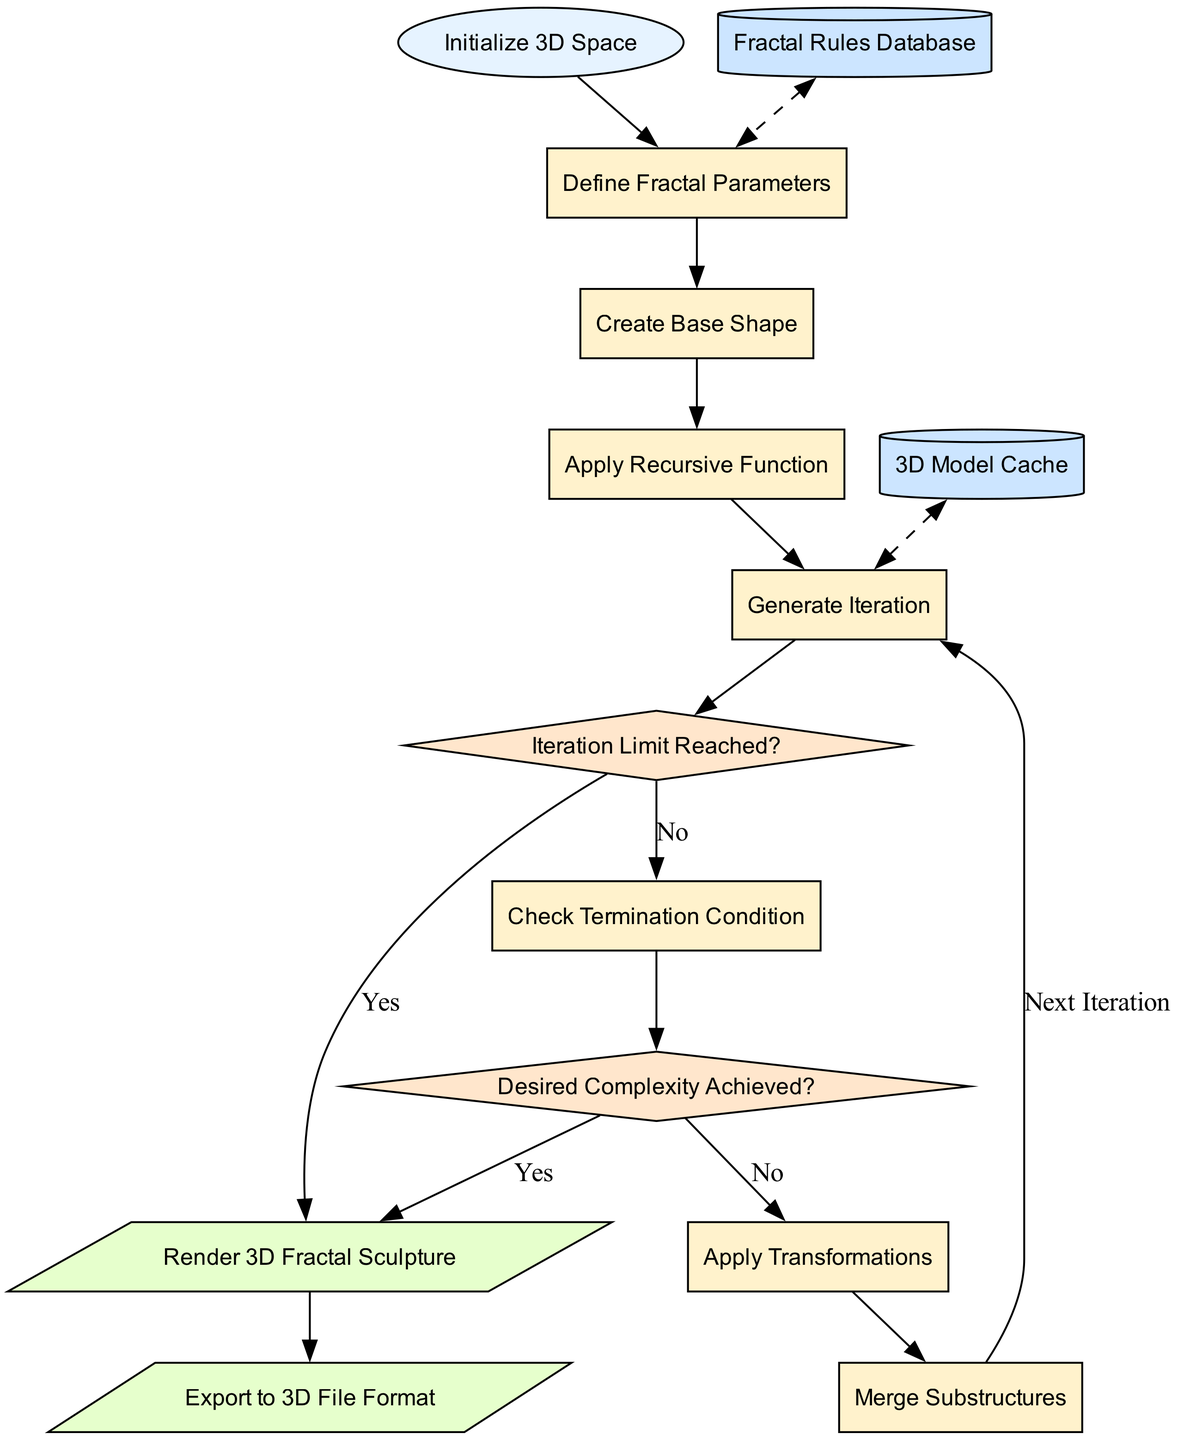What is the first process after the initialization? The flowchart starts with the "Initialize 3D Space" node, and the next process it leads to is "Define Fractal Parameters".
Answer: Define Fractal Parameters How many decision nodes are in the diagram? Upon examining the diagram, there are two decision nodes: "Iteration Limit Reached?" and "Desired Complexity Achieved?".
Answer: 2 What do we do if the iteration limit is reached? When the iteration limit is reached, the flow from the "Iteration Limit Reached?" decision node leads to the output node labeled "Render 3D Fractal Sculpture".
Answer: Render 3D Fractal Sculpture What is the last process before rendering the sculpture? The last process that occurs before rendering the sculpture is "Apply Transformations", following which the decision checks for the desired complexity.
Answer: Apply Transformations Which data store is used before defining the fractal parameters? The flow indicates that the "Fractal Rules Database" is accessed and used before the "Define Fractal Parameters" process.
Answer: Fractal Rules Database What happens when the desired complexity is achieved? If the "Desired Complexity Achieved?" decision returns "Yes", the flow leads to the output "Render 3D Fractal Sculpture".
Answer: Render 3D Fractal Sculpture How many processes are in the diagram? Counting the processes listed, there are a total of six processes in the flowchart.
Answer: 6 Where does the flowchart terminate? The flowchart terminates at the output node "Export to 3D File Format", following "Render 3D Fractal Sculpture".
Answer: Export to 3D File Format What is the significance of the dashed edges? The dashed edges represent interactions between the data stores and processes, indicating feedback loops for "Fractal Rules Database" and "3D Model Cache".
Answer: Feedback loops 